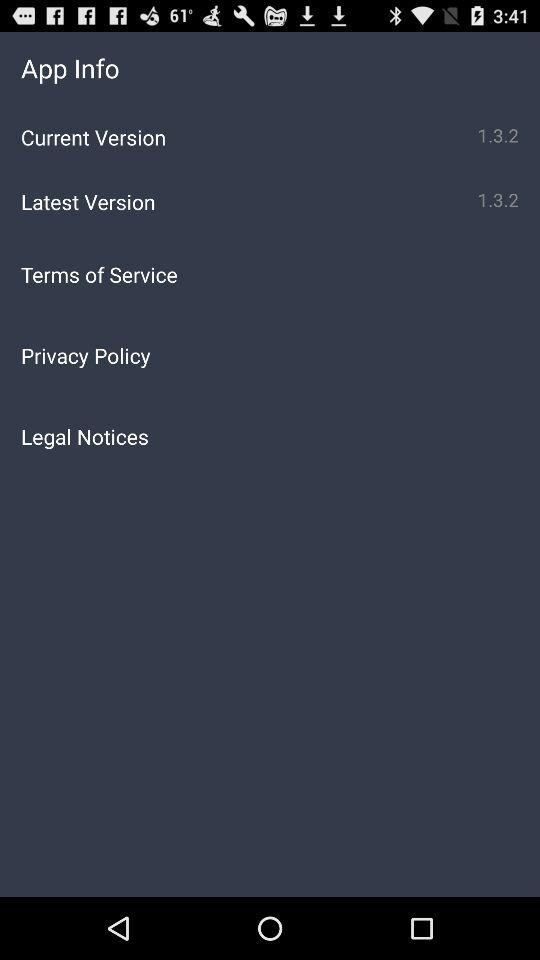How many items have a version number?
Answer the question using a single word or phrase. 2 